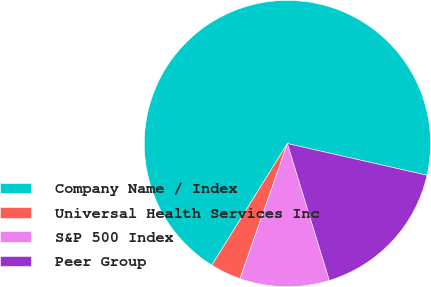Convert chart to OTSL. <chart><loc_0><loc_0><loc_500><loc_500><pie_chart><fcel>Company Name / Index<fcel>Universal Health Services Inc<fcel>S&P 500 Index<fcel>Peer Group<nl><fcel>69.7%<fcel>3.48%<fcel>10.1%<fcel>16.72%<nl></chart> 